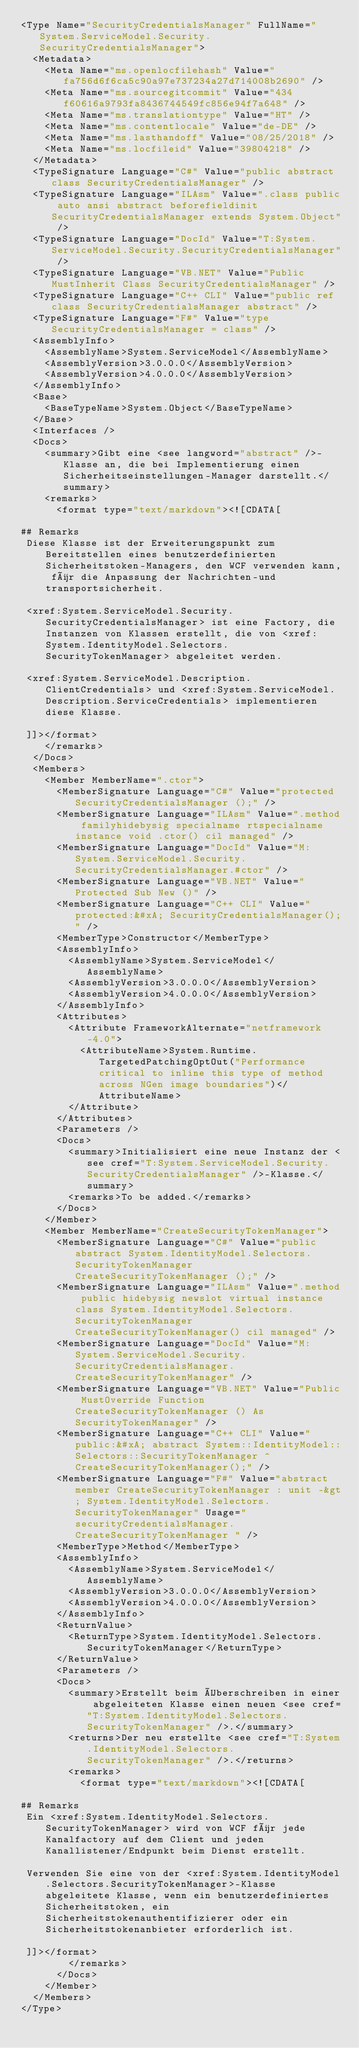<code> <loc_0><loc_0><loc_500><loc_500><_XML_><Type Name="SecurityCredentialsManager" FullName="System.ServiceModel.Security.SecurityCredentialsManager">
  <Metadata>
    <Meta Name="ms.openlocfilehash" Value="fa756d6f6ca5c90a97e737234a27d714008b2690" />
    <Meta Name="ms.sourcegitcommit" Value="434f60616a9793fa8436744549fc856e94f7a648" />
    <Meta Name="ms.translationtype" Value="HT" />
    <Meta Name="ms.contentlocale" Value="de-DE" />
    <Meta Name="ms.lasthandoff" Value="08/25/2018" />
    <Meta Name="ms.locfileid" Value="39804218" />
  </Metadata>
  <TypeSignature Language="C#" Value="public abstract class SecurityCredentialsManager" />
  <TypeSignature Language="ILAsm" Value=".class public auto ansi abstract beforefieldinit SecurityCredentialsManager extends System.Object" />
  <TypeSignature Language="DocId" Value="T:System.ServiceModel.Security.SecurityCredentialsManager" />
  <TypeSignature Language="VB.NET" Value="Public MustInherit Class SecurityCredentialsManager" />
  <TypeSignature Language="C++ CLI" Value="public ref class SecurityCredentialsManager abstract" />
  <TypeSignature Language="F#" Value="type SecurityCredentialsManager = class" />
  <AssemblyInfo>
    <AssemblyName>System.ServiceModel</AssemblyName>
    <AssemblyVersion>3.0.0.0</AssemblyVersion>
    <AssemblyVersion>4.0.0.0</AssemblyVersion>
  </AssemblyInfo>
  <Base>
    <BaseTypeName>System.Object</BaseTypeName>
  </Base>
  <Interfaces />
  <Docs>
    <summary>Gibt eine <see langword="abstract" />-Klasse an, die bei Implementierung einen Sicherheitseinstellungen-Manager darstellt.</summary>
    <remarks>
      <format type="text/markdown"><![CDATA[  
  
## Remarks  
 Diese Klasse ist der Erweiterungspunkt zum Bereitstellen eines benutzerdefinierten Sicherheitstoken-Managers, den WCF verwenden kann, für die Anpassung der Nachrichten-und transportsicherheit.  
  
 <xref:System.ServiceModel.Security.SecurityCredentialsManager> ist eine Factory, die Instanzen von Klassen erstellt, die von <xref:System.IdentityModel.Selectors.SecurityTokenManager> abgeleitet werden.  
  
 <xref:System.ServiceModel.Description.ClientCredentials> und <xref:System.ServiceModel.Description.ServiceCredentials> implementieren diese Klasse.  
  
 ]]></format>
    </remarks>
  </Docs>
  <Members>
    <Member MemberName=".ctor">
      <MemberSignature Language="C#" Value="protected SecurityCredentialsManager ();" />
      <MemberSignature Language="ILAsm" Value=".method familyhidebysig specialname rtspecialname instance void .ctor() cil managed" />
      <MemberSignature Language="DocId" Value="M:System.ServiceModel.Security.SecurityCredentialsManager.#ctor" />
      <MemberSignature Language="VB.NET" Value="Protected Sub New ()" />
      <MemberSignature Language="C++ CLI" Value="protected:&#xA; SecurityCredentialsManager();" />
      <MemberType>Constructor</MemberType>
      <AssemblyInfo>
        <AssemblyName>System.ServiceModel</AssemblyName>
        <AssemblyVersion>3.0.0.0</AssemblyVersion>
        <AssemblyVersion>4.0.0.0</AssemblyVersion>
      </AssemblyInfo>
      <Attributes>
        <Attribute FrameworkAlternate="netframework-4.0">
          <AttributeName>System.Runtime.TargetedPatchingOptOut("Performance critical to inline this type of method across NGen image boundaries")</AttributeName>
        </Attribute>
      </Attributes>
      <Parameters />
      <Docs>
        <summary>Initialisiert eine neue Instanz der <see cref="T:System.ServiceModel.Security.SecurityCredentialsManager" />-Klasse.</summary>
        <remarks>To be added.</remarks>
      </Docs>
    </Member>
    <Member MemberName="CreateSecurityTokenManager">
      <MemberSignature Language="C#" Value="public abstract System.IdentityModel.Selectors.SecurityTokenManager CreateSecurityTokenManager ();" />
      <MemberSignature Language="ILAsm" Value=".method public hidebysig newslot virtual instance class System.IdentityModel.Selectors.SecurityTokenManager CreateSecurityTokenManager() cil managed" />
      <MemberSignature Language="DocId" Value="M:System.ServiceModel.Security.SecurityCredentialsManager.CreateSecurityTokenManager" />
      <MemberSignature Language="VB.NET" Value="Public MustOverride Function CreateSecurityTokenManager () As SecurityTokenManager" />
      <MemberSignature Language="C++ CLI" Value="public:&#xA; abstract System::IdentityModel::Selectors::SecurityTokenManager ^ CreateSecurityTokenManager();" />
      <MemberSignature Language="F#" Value="abstract member CreateSecurityTokenManager : unit -&gt; System.IdentityModel.Selectors.SecurityTokenManager" Usage="securityCredentialsManager.CreateSecurityTokenManager " />
      <MemberType>Method</MemberType>
      <AssemblyInfo>
        <AssemblyName>System.ServiceModel</AssemblyName>
        <AssemblyVersion>3.0.0.0</AssemblyVersion>
        <AssemblyVersion>4.0.0.0</AssemblyVersion>
      </AssemblyInfo>
      <ReturnValue>
        <ReturnType>System.IdentityModel.Selectors.SecurityTokenManager</ReturnType>
      </ReturnValue>
      <Parameters />
      <Docs>
        <summary>Erstellt beim Überschreiben in einer abgeleiteten Klasse einen neuen <see cref="T:System.IdentityModel.Selectors.SecurityTokenManager" />.</summary>
        <returns>Der neu erstellte <see cref="T:System.IdentityModel.Selectors.SecurityTokenManager" />.</returns>
        <remarks>
          <format type="text/markdown"><![CDATA[  
  
## Remarks  
 Ein <xref:System.IdentityModel.Selectors.SecurityTokenManager> wird von WCF für jede Kanalfactory auf dem Client und jeden Kanallistener/Endpunkt beim Dienst erstellt.  
  
 Verwenden Sie eine von der <xref:System.IdentityModel.Selectors.SecurityTokenManager>-Klasse abgeleitete Klasse, wenn ein benutzerdefiniertes Sicherheitstoken, ein Sicherheitstokenauthentifizierer oder ein Sicherheitstokenanbieter erforderlich ist.  
  
 ]]></format>
        </remarks>
      </Docs>
    </Member>
  </Members>
</Type></code> 